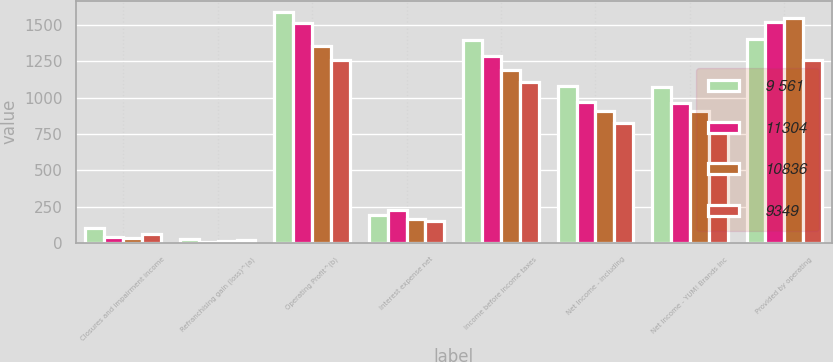Convert chart. <chart><loc_0><loc_0><loc_500><loc_500><stacked_bar_chart><ecel><fcel>Closures and impairment income<fcel>Refranchising gain (loss)^(a)<fcel>Operating Profit^(b)<fcel>Interest expense net<fcel>Income before income taxes<fcel>Net Income - including<fcel>Net Income - YUM! Brands Inc<fcel>Provided by operating<nl><fcel>9 561<fcel>103<fcel>26<fcel>1590<fcel>194<fcel>1396<fcel>1083<fcel>1071<fcel>1404<nl><fcel>11304<fcel>43<fcel>5<fcel>1517<fcel>226<fcel>1291<fcel>972<fcel>964<fcel>1521<nl><fcel>10836<fcel>35<fcel>11<fcel>1357<fcel>166<fcel>1191<fcel>909<fcel>909<fcel>1551<nl><fcel>9349<fcel>59<fcel>24<fcel>1262<fcel>154<fcel>1108<fcel>824<fcel>824<fcel>1257<nl></chart> 